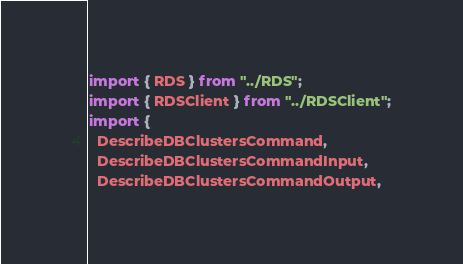<code> <loc_0><loc_0><loc_500><loc_500><_TypeScript_>import { RDS } from "../RDS";
import { RDSClient } from "../RDSClient";
import {
  DescribeDBClustersCommand,
  DescribeDBClustersCommandInput,
  DescribeDBClustersCommandOutput,</code> 